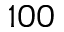Convert formula to latex. <formula><loc_0><loc_0><loc_500><loc_500>1 0 0</formula> 